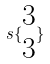<formula> <loc_0><loc_0><loc_500><loc_500>s \{ \begin{matrix} 3 \\ 3 \end{matrix} \}</formula> 